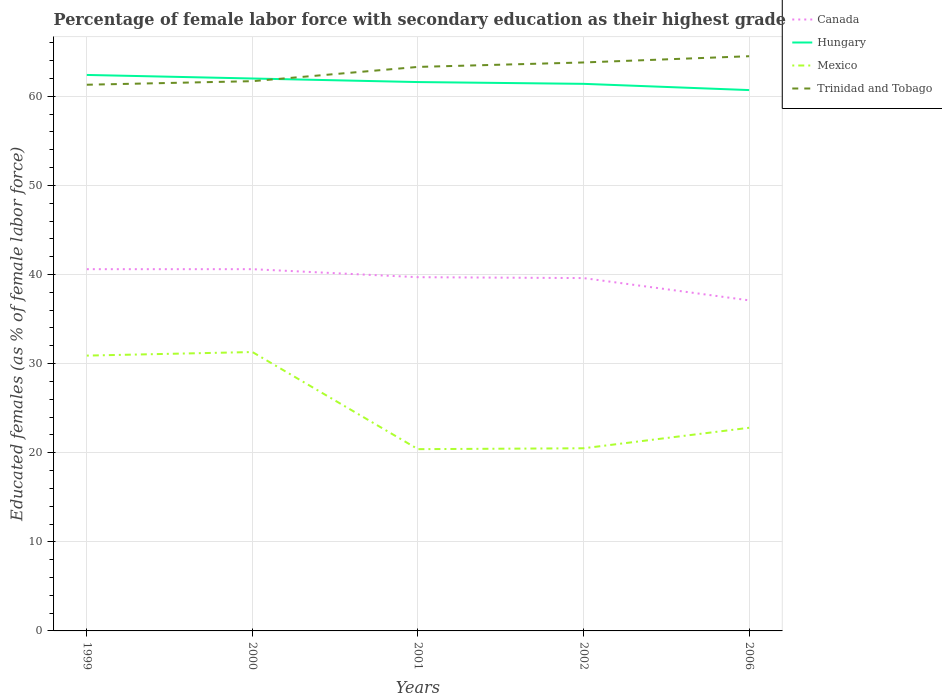How many different coloured lines are there?
Make the answer very short. 4. Does the line corresponding to Mexico intersect with the line corresponding to Trinidad and Tobago?
Offer a terse response. No. Across all years, what is the maximum percentage of female labor force with secondary education in Trinidad and Tobago?
Your answer should be very brief. 61.3. What is the total percentage of female labor force with secondary education in Mexico in the graph?
Offer a very short reply. 10.4. What is the difference between the highest and the second highest percentage of female labor force with secondary education in Hungary?
Offer a terse response. 1.7. Is the percentage of female labor force with secondary education in Hungary strictly greater than the percentage of female labor force with secondary education in Canada over the years?
Your answer should be compact. No. How many lines are there?
Offer a very short reply. 4. How many years are there in the graph?
Ensure brevity in your answer.  5. Are the values on the major ticks of Y-axis written in scientific E-notation?
Your answer should be compact. No. Does the graph contain any zero values?
Provide a succinct answer. No. Where does the legend appear in the graph?
Provide a short and direct response. Top right. How many legend labels are there?
Provide a succinct answer. 4. What is the title of the graph?
Make the answer very short. Percentage of female labor force with secondary education as their highest grade. Does "Tunisia" appear as one of the legend labels in the graph?
Your answer should be very brief. No. What is the label or title of the X-axis?
Give a very brief answer. Years. What is the label or title of the Y-axis?
Offer a terse response. Educated females (as % of female labor force). What is the Educated females (as % of female labor force) of Canada in 1999?
Give a very brief answer. 40.6. What is the Educated females (as % of female labor force) in Hungary in 1999?
Offer a very short reply. 62.4. What is the Educated females (as % of female labor force) in Mexico in 1999?
Your answer should be very brief. 30.9. What is the Educated females (as % of female labor force) of Trinidad and Tobago in 1999?
Keep it short and to the point. 61.3. What is the Educated females (as % of female labor force) in Canada in 2000?
Your answer should be very brief. 40.6. What is the Educated females (as % of female labor force) of Mexico in 2000?
Your answer should be very brief. 31.3. What is the Educated females (as % of female labor force) in Trinidad and Tobago in 2000?
Your response must be concise. 61.7. What is the Educated females (as % of female labor force) in Canada in 2001?
Ensure brevity in your answer.  39.7. What is the Educated females (as % of female labor force) in Hungary in 2001?
Keep it short and to the point. 61.6. What is the Educated females (as % of female labor force) in Mexico in 2001?
Give a very brief answer. 20.4. What is the Educated females (as % of female labor force) in Trinidad and Tobago in 2001?
Your answer should be compact. 63.3. What is the Educated females (as % of female labor force) of Canada in 2002?
Your response must be concise. 39.6. What is the Educated females (as % of female labor force) in Hungary in 2002?
Make the answer very short. 61.4. What is the Educated females (as % of female labor force) of Mexico in 2002?
Ensure brevity in your answer.  20.5. What is the Educated females (as % of female labor force) of Trinidad and Tobago in 2002?
Offer a terse response. 63.8. What is the Educated females (as % of female labor force) in Canada in 2006?
Make the answer very short. 37.1. What is the Educated females (as % of female labor force) of Hungary in 2006?
Provide a short and direct response. 60.7. What is the Educated females (as % of female labor force) in Mexico in 2006?
Give a very brief answer. 22.8. What is the Educated females (as % of female labor force) of Trinidad and Tobago in 2006?
Make the answer very short. 64.5. Across all years, what is the maximum Educated females (as % of female labor force) in Canada?
Ensure brevity in your answer.  40.6. Across all years, what is the maximum Educated females (as % of female labor force) of Hungary?
Make the answer very short. 62.4. Across all years, what is the maximum Educated females (as % of female labor force) in Mexico?
Provide a succinct answer. 31.3. Across all years, what is the maximum Educated females (as % of female labor force) of Trinidad and Tobago?
Offer a very short reply. 64.5. Across all years, what is the minimum Educated females (as % of female labor force) of Canada?
Provide a succinct answer. 37.1. Across all years, what is the minimum Educated females (as % of female labor force) in Hungary?
Keep it short and to the point. 60.7. Across all years, what is the minimum Educated females (as % of female labor force) of Mexico?
Make the answer very short. 20.4. Across all years, what is the minimum Educated females (as % of female labor force) of Trinidad and Tobago?
Your answer should be very brief. 61.3. What is the total Educated females (as % of female labor force) in Canada in the graph?
Offer a very short reply. 197.6. What is the total Educated females (as % of female labor force) in Hungary in the graph?
Offer a very short reply. 308.1. What is the total Educated females (as % of female labor force) of Mexico in the graph?
Make the answer very short. 125.9. What is the total Educated females (as % of female labor force) in Trinidad and Tobago in the graph?
Offer a very short reply. 314.6. What is the difference between the Educated females (as % of female labor force) in Canada in 1999 and that in 2000?
Offer a terse response. 0. What is the difference between the Educated females (as % of female labor force) in Hungary in 1999 and that in 2000?
Offer a terse response. 0.4. What is the difference between the Educated females (as % of female labor force) of Canada in 1999 and that in 2001?
Provide a short and direct response. 0.9. What is the difference between the Educated females (as % of female labor force) of Mexico in 1999 and that in 2001?
Ensure brevity in your answer.  10.5. What is the difference between the Educated females (as % of female labor force) of Trinidad and Tobago in 1999 and that in 2001?
Ensure brevity in your answer.  -2. What is the difference between the Educated females (as % of female labor force) in Mexico in 1999 and that in 2002?
Keep it short and to the point. 10.4. What is the difference between the Educated females (as % of female labor force) of Hungary in 1999 and that in 2006?
Provide a short and direct response. 1.7. What is the difference between the Educated females (as % of female labor force) of Mexico in 1999 and that in 2006?
Your answer should be compact. 8.1. What is the difference between the Educated females (as % of female labor force) in Trinidad and Tobago in 1999 and that in 2006?
Your answer should be very brief. -3.2. What is the difference between the Educated females (as % of female labor force) of Canada in 2000 and that in 2001?
Offer a very short reply. 0.9. What is the difference between the Educated females (as % of female labor force) of Canada in 2000 and that in 2002?
Provide a short and direct response. 1. What is the difference between the Educated females (as % of female labor force) of Hungary in 2000 and that in 2002?
Provide a short and direct response. 0.6. What is the difference between the Educated females (as % of female labor force) of Mexico in 2000 and that in 2002?
Keep it short and to the point. 10.8. What is the difference between the Educated females (as % of female labor force) of Trinidad and Tobago in 2000 and that in 2002?
Give a very brief answer. -2.1. What is the difference between the Educated females (as % of female labor force) of Canada in 2000 and that in 2006?
Make the answer very short. 3.5. What is the difference between the Educated females (as % of female labor force) in Hungary in 2000 and that in 2006?
Keep it short and to the point. 1.3. What is the difference between the Educated females (as % of female labor force) of Trinidad and Tobago in 2000 and that in 2006?
Make the answer very short. -2.8. What is the difference between the Educated females (as % of female labor force) in Canada in 2001 and that in 2002?
Provide a succinct answer. 0.1. What is the difference between the Educated females (as % of female labor force) in Trinidad and Tobago in 2001 and that in 2002?
Make the answer very short. -0.5. What is the difference between the Educated females (as % of female labor force) of Mexico in 2001 and that in 2006?
Your answer should be compact. -2.4. What is the difference between the Educated females (as % of female labor force) of Canada in 2002 and that in 2006?
Your answer should be compact. 2.5. What is the difference between the Educated females (as % of female labor force) in Hungary in 2002 and that in 2006?
Provide a succinct answer. 0.7. What is the difference between the Educated females (as % of female labor force) in Mexico in 2002 and that in 2006?
Ensure brevity in your answer.  -2.3. What is the difference between the Educated females (as % of female labor force) in Trinidad and Tobago in 2002 and that in 2006?
Provide a short and direct response. -0.7. What is the difference between the Educated females (as % of female labor force) of Canada in 1999 and the Educated females (as % of female labor force) of Hungary in 2000?
Keep it short and to the point. -21.4. What is the difference between the Educated females (as % of female labor force) in Canada in 1999 and the Educated females (as % of female labor force) in Trinidad and Tobago in 2000?
Give a very brief answer. -21.1. What is the difference between the Educated females (as % of female labor force) in Hungary in 1999 and the Educated females (as % of female labor force) in Mexico in 2000?
Your response must be concise. 31.1. What is the difference between the Educated females (as % of female labor force) in Mexico in 1999 and the Educated females (as % of female labor force) in Trinidad and Tobago in 2000?
Make the answer very short. -30.8. What is the difference between the Educated females (as % of female labor force) in Canada in 1999 and the Educated females (as % of female labor force) in Mexico in 2001?
Make the answer very short. 20.2. What is the difference between the Educated females (as % of female labor force) of Canada in 1999 and the Educated females (as % of female labor force) of Trinidad and Tobago in 2001?
Offer a terse response. -22.7. What is the difference between the Educated females (as % of female labor force) of Mexico in 1999 and the Educated females (as % of female labor force) of Trinidad and Tobago in 2001?
Your response must be concise. -32.4. What is the difference between the Educated females (as % of female labor force) of Canada in 1999 and the Educated females (as % of female labor force) of Hungary in 2002?
Ensure brevity in your answer.  -20.8. What is the difference between the Educated females (as % of female labor force) in Canada in 1999 and the Educated females (as % of female labor force) in Mexico in 2002?
Keep it short and to the point. 20.1. What is the difference between the Educated females (as % of female labor force) in Canada in 1999 and the Educated females (as % of female labor force) in Trinidad and Tobago in 2002?
Offer a terse response. -23.2. What is the difference between the Educated females (as % of female labor force) in Hungary in 1999 and the Educated females (as % of female labor force) in Mexico in 2002?
Keep it short and to the point. 41.9. What is the difference between the Educated females (as % of female labor force) in Mexico in 1999 and the Educated females (as % of female labor force) in Trinidad and Tobago in 2002?
Provide a short and direct response. -32.9. What is the difference between the Educated females (as % of female labor force) in Canada in 1999 and the Educated females (as % of female labor force) in Hungary in 2006?
Give a very brief answer. -20.1. What is the difference between the Educated females (as % of female labor force) of Canada in 1999 and the Educated females (as % of female labor force) of Mexico in 2006?
Keep it short and to the point. 17.8. What is the difference between the Educated females (as % of female labor force) of Canada in 1999 and the Educated females (as % of female labor force) of Trinidad and Tobago in 2006?
Offer a terse response. -23.9. What is the difference between the Educated females (as % of female labor force) in Hungary in 1999 and the Educated females (as % of female labor force) in Mexico in 2006?
Your answer should be compact. 39.6. What is the difference between the Educated females (as % of female labor force) of Mexico in 1999 and the Educated females (as % of female labor force) of Trinidad and Tobago in 2006?
Provide a succinct answer. -33.6. What is the difference between the Educated females (as % of female labor force) in Canada in 2000 and the Educated females (as % of female labor force) in Hungary in 2001?
Your response must be concise. -21. What is the difference between the Educated females (as % of female labor force) of Canada in 2000 and the Educated females (as % of female labor force) of Mexico in 2001?
Provide a short and direct response. 20.2. What is the difference between the Educated females (as % of female labor force) in Canada in 2000 and the Educated females (as % of female labor force) in Trinidad and Tobago in 2001?
Provide a succinct answer. -22.7. What is the difference between the Educated females (as % of female labor force) in Hungary in 2000 and the Educated females (as % of female labor force) in Mexico in 2001?
Offer a terse response. 41.6. What is the difference between the Educated females (as % of female labor force) of Hungary in 2000 and the Educated females (as % of female labor force) of Trinidad and Tobago in 2001?
Your answer should be very brief. -1.3. What is the difference between the Educated females (as % of female labor force) in Mexico in 2000 and the Educated females (as % of female labor force) in Trinidad and Tobago in 2001?
Ensure brevity in your answer.  -32. What is the difference between the Educated females (as % of female labor force) in Canada in 2000 and the Educated females (as % of female labor force) in Hungary in 2002?
Your response must be concise. -20.8. What is the difference between the Educated females (as % of female labor force) in Canada in 2000 and the Educated females (as % of female labor force) in Mexico in 2002?
Offer a terse response. 20.1. What is the difference between the Educated females (as % of female labor force) in Canada in 2000 and the Educated females (as % of female labor force) in Trinidad and Tobago in 2002?
Provide a succinct answer. -23.2. What is the difference between the Educated females (as % of female labor force) in Hungary in 2000 and the Educated females (as % of female labor force) in Mexico in 2002?
Your answer should be compact. 41.5. What is the difference between the Educated females (as % of female labor force) in Mexico in 2000 and the Educated females (as % of female labor force) in Trinidad and Tobago in 2002?
Your answer should be compact. -32.5. What is the difference between the Educated females (as % of female labor force) of Canada in 2000 and the Educated females (as % of female labor force) of Hungary in 2006?
Ensure brevity in your answer.  -20.1. What is the difference between the Educated females (as % of female labor force) of Canada in 2000 and the Educated females (as % of female labor force) of Trinidad and Tobago in 2006?
Your response must be concise. -23.9. What is the difference between the Educated females (as % of female labor force) of Hungary in 2000 and the Educated females (as % of female labor force) of Mexico in 2006?
Your answer should be very brief. 39.2. What is the difference between the Educated females (as % of female labor force) of Hungary in 2000 and the Educated females (as % of female labor force) of Trinidad and Tobago in 2006?
Keep it short and to the point. -2.5. What is the difference between the Educated females (as % of female labor force) in Mexico in 2000 and the Educated females (as % of female labor force) in Trinidad and Tobago in 2006?
Make the answer very short. -33.2. What is the difference between the Educated females (as % of female labor force) in Canada in 2001 and the Educated females (as % of female labor force) in Hungary in 2002?
Your answer should be compact. -21.7. What is the difference between the Educated females (as % of female labor force) in Canada in 2001 and the Educated females (as % of female labor force) in Trinidad and Tobago in 2002?
Make the answer very short. -24.1. What is the difference between the Educated females (as % of female labor force) of Hungary in 2001 and the Educated females (as % of female labor force) of Mexico in 2002?
Give a very brief answer. 41.1. What is the difference between the Educated females (as % of female labor force) in Hungary in 2001 and the Educated females (as % of female labor force) in Trinidad and Tobago in 2002?
Provide a short and direct response. -2.2. What is the difference between the Educated females (as % of female labor force) in Mexico in 2001 and the Educated females (as % of female labor force) in Trinidad and Tobago in 2002?
Your answer should be compact. -43.4. What is the difference between the Educated females (as % of female labor force) of Canada in 2001 and the Educated females (as % of female labor force) of Mexico in 2006?
Provide a short and direct response. 16.9. What is the difference between the Educated females (as % of female labor force) of Canada in 2001 and the Educated females (as % of female labor force) of Trinidad and Tobago in 2006?
Keep it short and to the point. -24.8. What is the difference between the Educated females (as % of female labor force) in Hungary in 2001 and the Educated females (as % of female labor force) in Mexico in 2006?
Provide a short and direct response. 38.8. What is the difference between the Educated females (as % of female labor force) of Hungary in 2001 and the Educated females (as % of female labor force) of Trinidad and Tobago in 2006?
Give a very brief answer. -2.9. What is the difference between the Educated females (as % of female labor force) of Mexico in 2001 and the Educated females (as % of female labor force) of Trinidad and Tobago in 2006?
Offer a very short reply. -44.1. What is the difference between the Educated females (as % of female labor force) in Canada in 2002 and the Educated females (as % of female labor force) in Hungary in 2006?
Provide a succinct answer. -21.1. What is the difference between the Educated females (as % of female labor force) of Canada in 2002 and the Educated females (as % of female labor force) of Mexico in 2006?
Give a very brief answer. 16.8. What is the difference between the Educated females (as % of female labor force) in Canada in 2002 and the Educated females (as % of female labor force) in Trinidad and Tobago in 2006?
Your answer should be compact. -24.9. What is the difference between the Educated females (as % of female labor force) in Hungary in 2002 and the Educated females (as % of female labor force) in Mexico in 2006?
Offer a terse response. 38.6. What is the difference between the Educated females (as % of female labor force) in Mexico in 2002 and the Educated females (as % of female labor force) in Trinidad and Tobago in 2006?
Make the answer very short. -44. What is the average Educated females (as % of female labor force) in Canada per year?
Your response must be concise. 39.52. What is the average Educated females (as % of female labor force) in Hungary per year?
Offer a terse response. 61.62. What is the average Educated females (as % of female labor force) in Mexico per year?
Ensure brevity in your answer.  25.18. What is the average Educated females (as % of female labor force) of Trinidad and Tobago per year?
Offer a terse response. 62.92. In the year 1999, what is the difference between the Educated females (as % of female labor force) in Canada and Educated females (as % of female labor force) in Hungary?
Ensure brevity in your answer.  -21.8. In the year 1999, what is the difference between the Educated females (as % of female labor force) of Canada and Educated females (as % of female labor force) of Trinidad and Tobago?
Your response must be concise. -20.7. In the year 1999, what is the difference between the Educated females (as % of female labor force) in Hungary and Educated females (as % of female labor force) in Mexico?
Ensure brevity in your answer.  31.5. In the year 1999, what is the difference between the Educated females (as % of female labor force) of Mexico and Educated females (as % of female labor force) of Trinidad and Tobago?
Provide a succinct answer. -30.4. In the year 2000, what is the difference between the Educated females (as % of female labor force) in Canada and Educated females (as % of female labor force) in Hungary?
Give a very brief answer. -21.4. In the year 2000, what is the difference between the Educated females (as % of female labor force) of Canada and Educated females (as % of female labor force) of Trinidad and Tobago?
Make the answer very short. -21.1. In the year 2000, what is the difference between the Educated females (as % of female labor force) of Hungary and Educated females (as % of female labor force) of Mexico?
Offer a very short reply. 30.7. In the year 2000, what is the difference between the Educated females (as % of female labor force) of Hungary and Educated females (as % of female labor force) of Trinidad and Tobago?
Make the answer very short. 0.3. In the year 2000, what is the difference between the Educated females (as % of female labor force) in Mexico and Educated females (as % of female labor force) in Trinidad and Tobago?
Give a very brief answer. -30.4. In the year 2001, what is the difference between the Educated females (as % of female labor force) of Canada and Educated females (as % of female labor force) of Hungary?
Make the answer very short. -21.9. In the year 2001, what is the difference between the Educated females (as % of female labor force) of Canada and Educated females (as % of female labor force) of Mexico?
Provide a succinct answer. 19.3. In the year 2001, what is the difference between the Educated females (as % of female labor force) in Canada and Educated females (as % of female labor force) in Trinidad and Tobago?
Keep it short and to the point. -23.6. In the year 2001, what is the difference between the Educated females (as % of female labor force) in Hungary and Educated females (as % of female labor force) in Mexico?
Give a very brief answer. 41.2. In the year 2001, what is the difference between the Educated females (as % of female labor force) in Mexico and Educated females (as % of female labor force) in Trinidad and Tobago?
Your answer should be compact. -42.9. In the year 2002, what is the difference between the Educated females (as % of female labor force) of Canada and Educated females (as % of female labor force) of Hungary?
Offer a terse response. -21.8. In the year 2002, what is the difference between the Educated females (as % of female labor force) of Canada and Educated females (as % of female labor force) of Mexico?
Ensure brevity in your answer.  19.1. In the year 2002, what is the difference between the Educated females (as % of female labor force) in Canada and Educated females (as % of female labor force) in Trinidad and Tobago?
Ensure brevity in your answer.  -24.2. In the year 2002, what is the difference between the Educated females (as % of female labor force) in Hungary and Educated females (as % of female labor force) in Mexico?
Offer a very short reply. 40.9. In the year 2002, what is the difference between the Educated females (as % of female labor force) of Mexico and Educated females (as % of female labor force) of Trinidad and Tobago?
Your response must be concise. -43.3. In the year 2006, what is the difference between the Educated females (as % of female labor force) in Canada and Educated females (as % of female labor force) in Hungary?
Give a very brief answer. -23.6. In the year 2006, what is the difference between the Educated females (as % of female labor force) of Canada and Educated females (as % of female labor force) of Trinidad and Tobago?
Offer a terse response. -27.4. In the year 2006, what is the difference between the Educated females (as % of female labor force) of Hungary and Educated females (as % of female labor force) of Mexico?
Your answer should be very brief. 37.9. In the year 2006, what is the difference between the Educated females (as % of female labor force) in Hungary and Educated females (as % of female labor force) in Trinidad and Tobago?
Give a very brief answer. -3.8. In the year 2006, what is the difference between the Educated females (as % of female labor force) in Mexico and Educated females (as % of female labor force) in Trinidad and Tobago?
Your response must be concise. -41.7. What is the ratio of the Educated females (as % of female labor force) in Mexico in 1999 to that in 2000?
Keep it short and to the point. 0.99. What is the ratio of the Educated females (as % of female labor force) in Canada in 1999 to that in 2001?
Keep it short and to the point. 1.02. What is the ratio of the Educated females (as % of female labor force) in Hungary in 1999 to that in 2001?
Your answer should be compact. 1.01. What is the ratio of the Educated females (as % of female labor force) of Mexico in 1999 to that in 2001?
Provide a succinct answer. 1.51. What is the ratio of the Educated females (as % of female labor force) of Trinidad and Tobago in 1999 to that in 2001?
Give a very brief answer. 0.97. What is the ratio of the Educated females (as % of female labor force) of Canada in 1999 to that in 2002?
Make the answer very short. 1.03. What is the ratio of the Educated females (as % of female labor force) of Hungary in 1999 to that in 2002?
Make the answer very short. 1.02. What is the ratio of the Educated females (as % of female labor force) in Mexico in 1999 to that in 2002?
Keep it short and to the point. 1.51. What is the ratio of the Educated females (as % of female labor force) of Trinidad and Tobago in 1999 to that in 2002?
Your answer should be compact. 0.96. What is the ratio of the Educated females (as % of female labor force) in Canada in 1999 to that in 2006?
Offer a very short reply. 1.09. What is the ratio of the Educated females (as % of female labor force) of Hungary in 1999 to that in 2006?
Your response must be concise. 1.03. What is the ratio of the Educated females (as % of female labor force) of Mexico in 1999 to that in 2006?
Keep it short and to the point. 1.36. What is the ratio of the Educated females (as % of female labor force) of Trinidad and Tobago in 1999 to that in 2006?
Provide a short and direct response. 0.95. What is the ratio of the Educated females (as % of female labor force) in Canada in 2000 to that in 2001?
Offer a very short reply. 1.02. What is the ratio of the Educated females (as % of female labor force) in Mexico in 2000 to that in 2001?
Ensure brevity in your answer.  1.53. What is the ratio of the Educated females (as % of female labor force) in Trinidad and Tobago in 2000 to that in 2001?
Ensure brevity in your answer.  0.97. What is the ratio of the Educated females (as % of female labor force) in Canada in 2000 to that in 2002?
Keep it short and to the point. 1.03. What is the ratio of the Educated females (as % of female labor force) in Hungary in 2000 to that in 2002?
Offer a very short reply. 1.01. What is the ratio of the Educated females (as % of female labor force) in Mexico in 2000 to that in 2002?
Offer a very short reply. 1.53. What is the ratio of the Educated females (as % of female labor force) of Trinidad and Tobago in 2000 to that in 2002?
Your answer should be compact. 0.97. What is the ratio of the Educated females (as % of female labor force) of Canada in 2000 to that in 2006?
Your answer should be very brief. 1.09. What is the ratio of the Educated females (as % of female labor force) of Hungary in 2000 to that in 2006?
Keep it short and to the point. 1.02. What is the ratio of the Educated females (as % of female labor force) in Mexico in 2000 to that in 2006?
Your answer should be compact. 1.37. What is the ratio of the Educated females (as % of female labor force) in Trinidad and Tobago in 2000 to that in 2006?
Offer a terse response. 0.96. What is the ratio of the Educated females (as % of female labor force) in Trinidad and Tobago in 2001 to that in 2002?
Provide a short and direct response. 0.99. What is the ratio of the Educated females (as % of female labor force) in Canada in 2001 to that in 2006?
Offer a very short reply. 1.07. What is the ratio of the Educated females (as % of female labor force) of Hungary in 2001 to that in 2006?
Offer a terse response. 1.01. What is the ratio of the Educated females (as % of female labor force) of Mexico in 2001 to that in 2006?
Make the answer very short. 0.89. What is the ratio of the Educated females (as % of female labor force) of Trinidad and Tobago in 2001 to that in 2006?
Your response must be concise. 0.98. What is the ratio of the Educated females (as % of female labor force) in Canada in 2002 to that in 2006?
Give a very brief answer. 1.07. What is the ratio of the Educated females (as % of female labor force) of Hungary in 2002 to that in 2006?
Your response must be concise. 1.01. What is the ratio of the Educated females (as % of female labor force) of Mexico in 2002 to that in 2006?
Give a very brief answer. 0.9. What is the difference between the highest and the second highest Educated females (as % of female labor force) in Canada?
Your answer should be very brief. 0. What is the difference between the highest and the second highest Educated females (as % of female labor force) in Trinidad and Tobago?
Provide a short and direct response. 0.7. What is the difference between the highest and the lowest Educated females (as % of female labor force) in Trinidad and Tobago?
Offer a terse response. 3.2. 